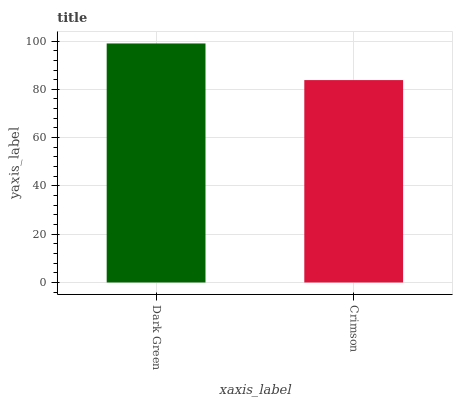Is Crimson the minimum?
Answer yes or no. Yes. Is Dark Green the maximum?
Answer yes or no. Yes. Is Crimson the maximum?
Answer yes or no. No. Is Dark Green greater than Crimson?
Answer yes or no. Yes. Is Crimson less than Dark Green?
Answer yes or no. Yes. Is Crimson greater than Dark Green?
Answer yes or no. No. Is Dark Green less than Crimson?
Answer yes or no. No. Is Dark Green the high median?
Answer yes or no. Yes. Is Crimson the low median?
Answer yes or no. Yes. Is Crimson the high median?
Answer yes or no. No. Is Dark Green the low median?
Answer yes or no. No. 